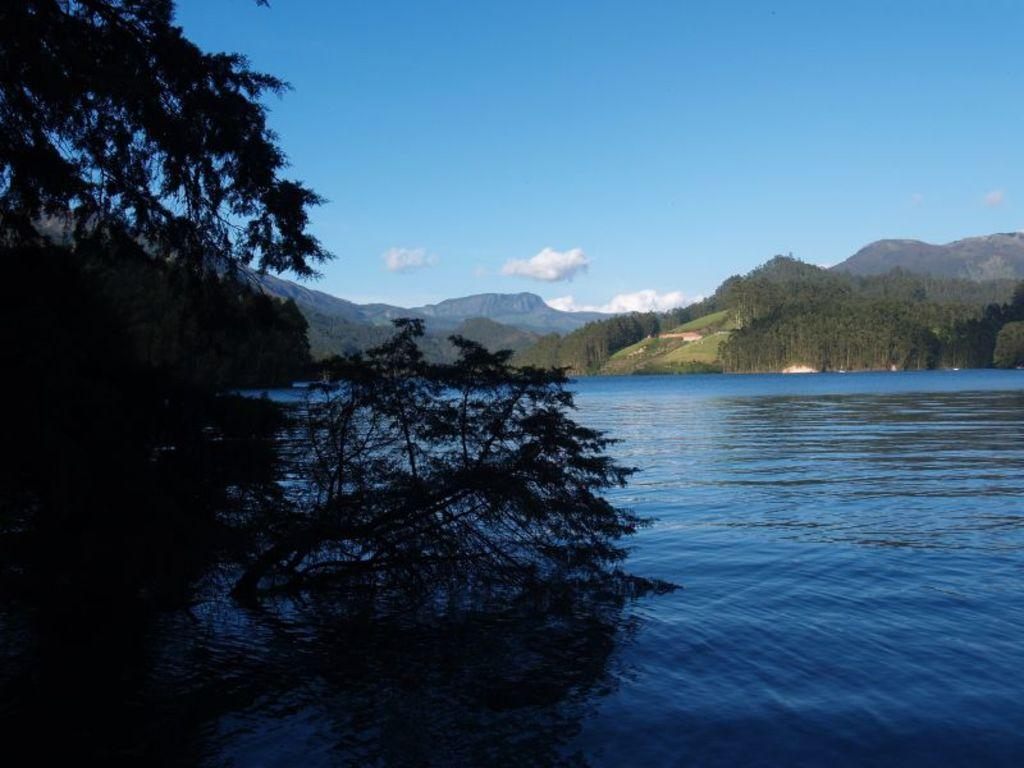What is the primary element flowing in the image? There is water flowing in the image. What type of geographical feature can be seen in the image? There are mountains with grass in the image. What kind of vegetation is present in the image? There are trees with branches and leaves in the image. What can be seen in the sky in the image? There are clouds visible in the sky. What type of loaf is being baked in the image? There is no loaf or baking activity present in the image; it features water flowing, mountains, trees, and clouds. How much coal is visible in the image? There is no coal present in the image. 